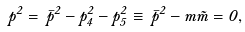<formula> <loc_0><loc_0><loc_500><loc_500>p ^ { 2 } = \, \bar { p } ^ { 2 } - p _ { 4 } ^ { 2 } - p _ { 5 } ^ { 2 } \equiv \, \bar { p } ^ { 2 } - m \tilde { m } = 0 ,</formula> 